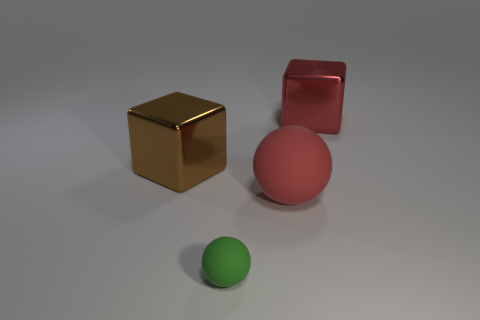Can you describe the shapes and colors visible in the image? Certainly! The image features four objects: two blocks and two spheres. The blocks are gold and red, while the spheres are red and green. The objects are placed on a grey surface with a shadow indicating a light source from above. 